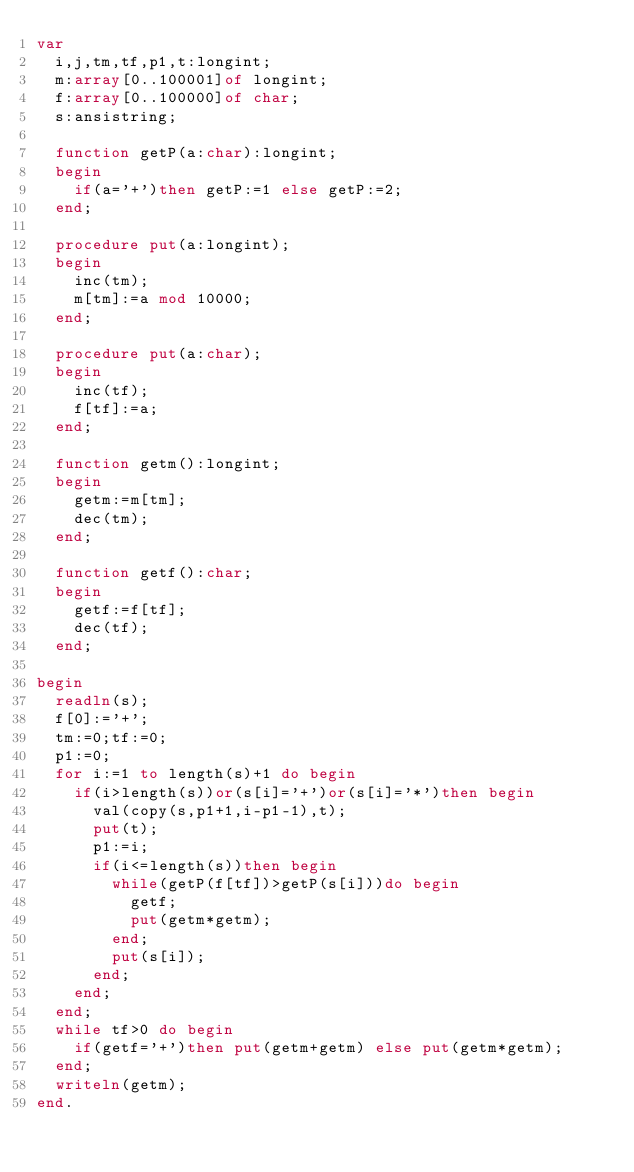Convert code to text. <code><loc_0><loc_0><loc_500><loc_500><_Pascal_>var
  i,j,tm,tf,p1,t:longint;
  m:array[0..100001]of longint;
  f:array[0..100000]of char;
  s:ansistring;

  function getP(a:char):longint;
  begin
    if(a='+')then getP:=1 else getP:=2;
  end;

  procedure put(a:longint);
  begin
    inc(tm);
    m[tm]:=a mod 10000;
  end;

  procedure put(a:char);
  begin
    inc(tf);
    f[tf]:=a;
  end;

  function getm():longint;
  begin
    getm:=m[tm];
    dec(tm);
  end;

  function getf():char;
  begin
    getf:=f[tf];
    dec(tf);
  end;

begin
  readln(s);
  f[0]:='+';
  tm:=0;tf:=0;
  p1:=0;
  for i:=1 to length(s)+1 do begin
    if(i>length(s))or(s[i]='+')or(s[i]='*')then begin
      val(copy(s,p1+1,i-p1-1),t);
      put(t);
      p1:=i;
      if(i<=length(s))then begin
        while(getP(f[tf])>getP(s[i]))do begin
          getf;
          put(getm*getm);
        end;
        put(s[i]);
      end;
    end;
  end;
  while tf>0 do begin
    if(getf='+')then put(getm+getm) else put(getm*getm);
  end;
  writeln(getm);
end.
</code> 